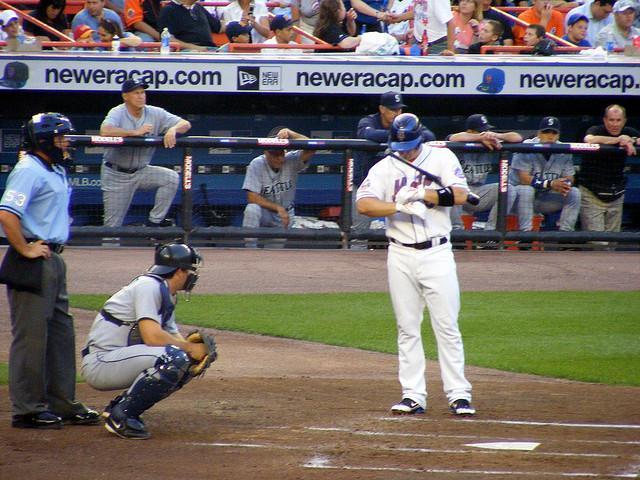How many people are in the photo?
Give a very brief answer. 10. How many cups are on the table?
Give a very brief answer. 0. 